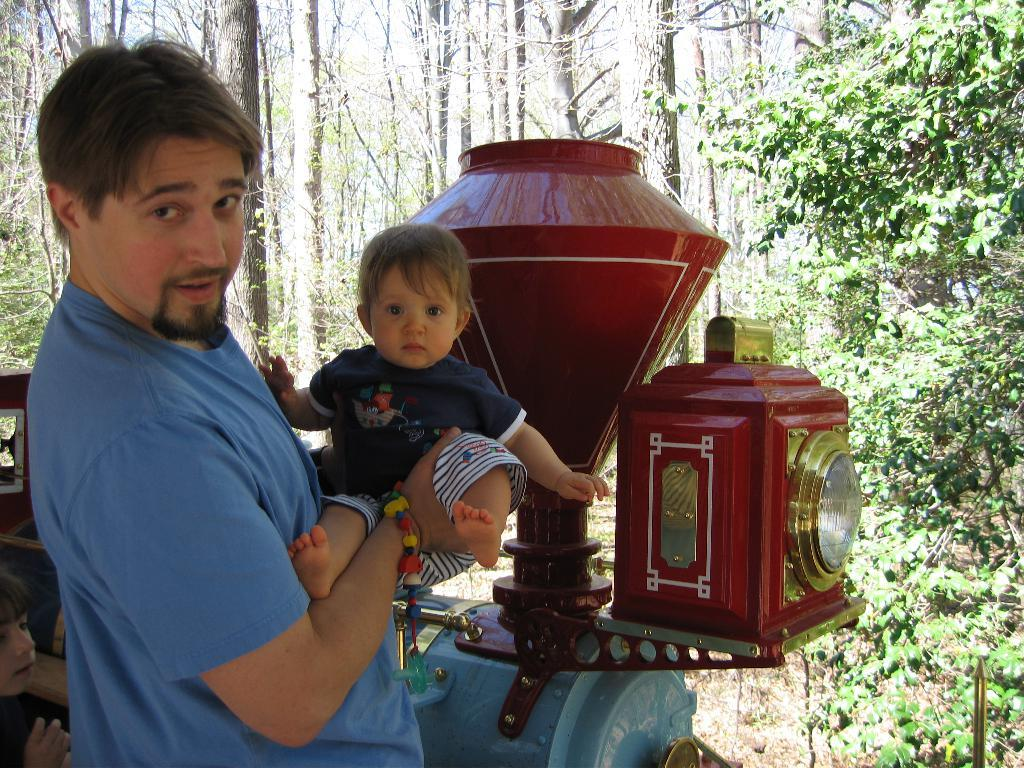What is the person in the image holding? The person is holding a baby in the image. What type of toy can be seen in the image? There is a toy train in the image. Where is the child located in the image? The child is in the bottom left corner of the image. What can be seen under the people and toys in the image? The ground is visible in the image. What type of vegetation is present in the image? There are plants and trees in the image. Is there a man standing in the rain in the image? There is no man standing in the rain in the image. Can you see a hole in the ground in the image? There is no hole visible in the ground in the image. 